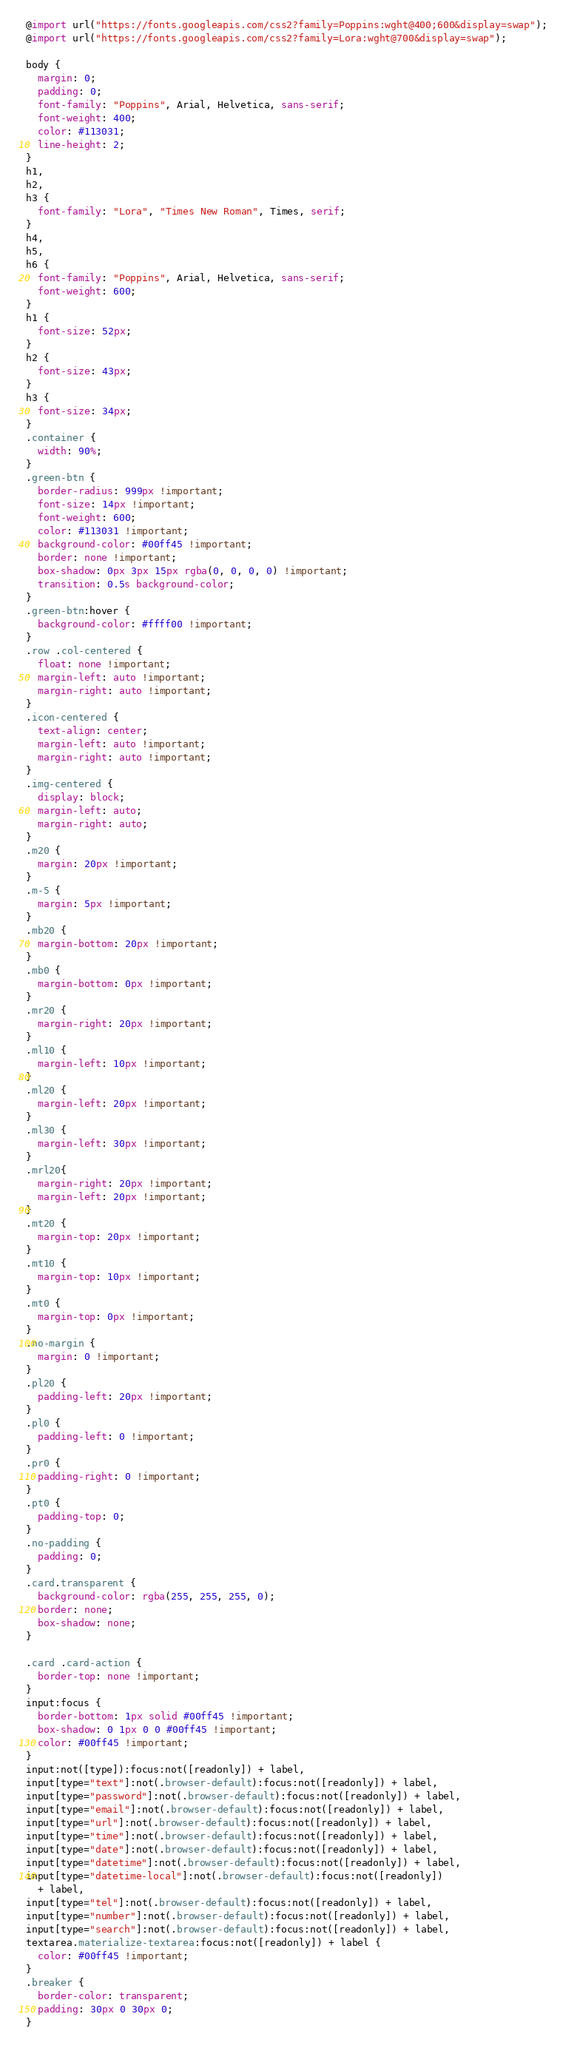<code> <loc_0><loc_0><loc_500><loc_500><_CSS_>@import url("https://fonts.googleapis.com/css2?family=Poppins:wght@400;600&display=swap");
@import url("https://fonts.googleapis.com/css2?family=Lora:wght@700&display=swap");

body {
  margin: 0;
  padding: 0;
  font-family: "Poppins", Arial, Helvetica, sans-serif;
  font-weight: 400;
  color: #113031;
  line-height: 2;
}
h1,
h2,
h3 {
  font-family: "Lora", "Times New Roman", Times, serif;
}
h4,
h5,
h6 {
  font-family: "Poppins", Arial, Helvetica, sans-serif;
  font-weight: 600;
}
h1 {
  font-size: 52px;
}
h2 {
  font-size: 43px;
}
h3 {
  font-size: 34px;
}
.container {
  width: 90%;
}
.green-btn {
  border-radius: 999px !important;
  font-size: 14px !important;
  font-weight: 600;
  color: #113031 !important;
  background-color: #00ff45 !important;
  border: none !important;
  box-shadow: 0px 3px 15px rgba(0, 0, 0, 0) !important;
  transition: 0.5s background-color;
}
.green-btn:hover {
  background-color: #ffff00 !important;
}
.row .col-centered {
  float: none !important;
  margin-left: auto !important;
  margin-right: auto !important;
}
.icon-centered {
  text-align: center;
  margin-left: auto !important;
  margin-right: auto !important;
}
.img-centered {
  display: block;
  margin-left: auto;
  margin-right: auto;
}
.m20 {
  margin: 20px !important;
}
.m-5 {
  margin: 5px !important;
}
.mb20 {
  margin-bottom: 20px !important;
}
.mb0 {
  margin-bottom: 0px !important;
}
.mr20 {
  margin-right: 20px !important;
}
.ml10 {
  margin-left: 10px !important;
}
.ml20 {
  margin-left: 20px !important;
}
.ml30 {
  margin-left: 30px !important;
}
.mrl20{
  margin-right: 20px !important;
  margin-left: 20px !important;
}
.mt20 {
  margin-top: 20px !important;
}
.mt10 {
  margin-top: 10px !important;
}
.mt0 {
  margin-top: 0px !important;
}
.no-margin {
  margin: 0 !important;
}
.pl20 {
  padding-left: 20px !important;
}
.pl0 {
  padding-left: 0 !important;
}
.pr0 {
  padding-right: 0 !important;
}
.pt0 {
  padding-top: 0;
}
.no-padding {
  padding: 0;
}
.card.transparent {
  background-color: rgba(255, 255, 255, 0);
  border: none;
  box-shadow: none;
}

.card .card-action {
  border-top: none !important;
}
input:focus {
  border-bottom: 1px solid #00ff45 !important;
  box-shadow: 0 1px 0 0 #00ff45 !important;
  color: #00ff45 !important;
}
input:not([type]):focus:not([readonly]) + label,
input[type="text"]:not(.browser-default):focus:not([readonly]) + label,
input[type="password"]:not(.browser-default):focus:not([readonly]) + label,
input[type="email"]:not(.browser-default):focus:not([readonly]) + label,
input[type="url"]:not(.browser-default):focus:not([readonly]) + label,
input[type="time"]:not(.browser-default):focus:not([readonly]) + label,
input[type="date"]:not(.browser-default):focus:not([readonly]) + label,
input[type="datetime"]:not(.browser-default):focus:not([readonly]) + label,
input[type="datetime-local"]:not(.browser-default):focus:not([readonly])
  + label,
input[type="tel"]:not(.browser-default):focus:not([readonly]) + label,
input[type="number"]:not(.browser-default):focus:not([readonly]) + label,
input[type="search"]:not(.browser-default):focus:not([readonly]) + label,
textarea.materialize-textarea:focus:not([readonly]) + label {
  color: #00ff45 !important;
}
.breaker {
  border-color: transparent;
  padding: 30px 0 30px 0;
}</code> 